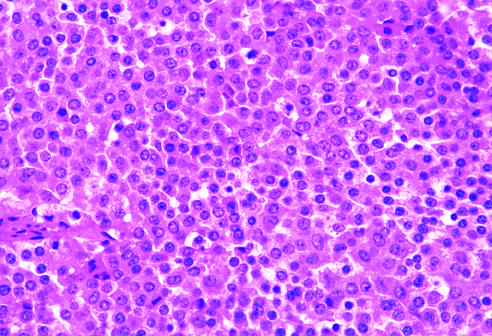what contrasts with the admixture of cells seen in the normal anterior pituitary gland?
Answer the question using a single word or phrase. The monomorphism of these cells 